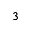Convert formula to latex. <formula><loc_0><loc_0><loc_500><loc_500>_ { 3 }</formula> 